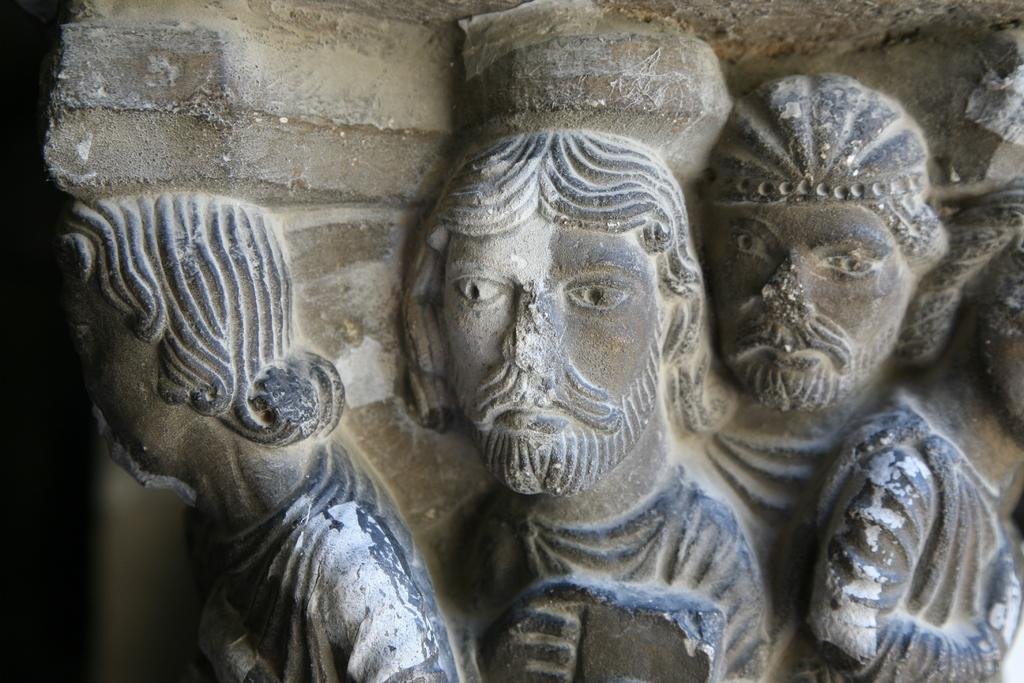What is depicted in the image? There is a carving in the image. Can you describe the condition of the carving? The carving is damaged and broken. Where is the queen receiving treatment in the image? There is no queen or hospital present in the image; it features a damaged and broken carving. What part of the carving is missing in the image? The image does not specify any missing parts of the carving; it only mentions that the carving is damaged and broken. 